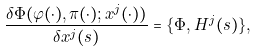Convert formula to latex. <formula><loc_0><loc_0><loc_500><loc_500>\frac { \delta \Phi ( \varphi ( \cdot ) , \pi ( \cdot ) ; x ^ { j } ( \cdot ) ) } { \delta x ^ { j } ( s ) } = \{ \Phi , H ^ { j } ( s ) \} ,</formula> 